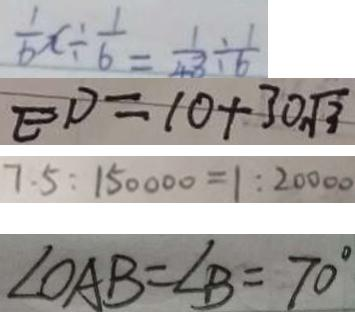Convert formula to latex. <formula><loc_0><loc_0><loc_500><loc_500>\frac { 1 } { 6 } x \div \frac { 1 } { 6 } = \frac { 1 } { 4 3 } \div \frac { 1 } { 6 } 
 E D = 1 0 + 3 0 \sqrt { 3 } 
 7 . 5 : 1 5 0 0 0 0 = 1 : 2 0 0 0 0 
 \angle O A B = \angle B = 7 0 ^ { \circ }</formula> 